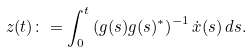<formula> <loc_0><loc_0><loc_500><loc_500>z ( t ) \colon = \int _ { 0 } ^ { t } \left ( g ( s ) g ( s ) ^ { * } \right ) ^ { - 1 } \dot { x } ( s ) \, d s .</formula> 